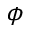<formula> <loc_0><loc_0><loc_500><loc_500>\phi</formula> 